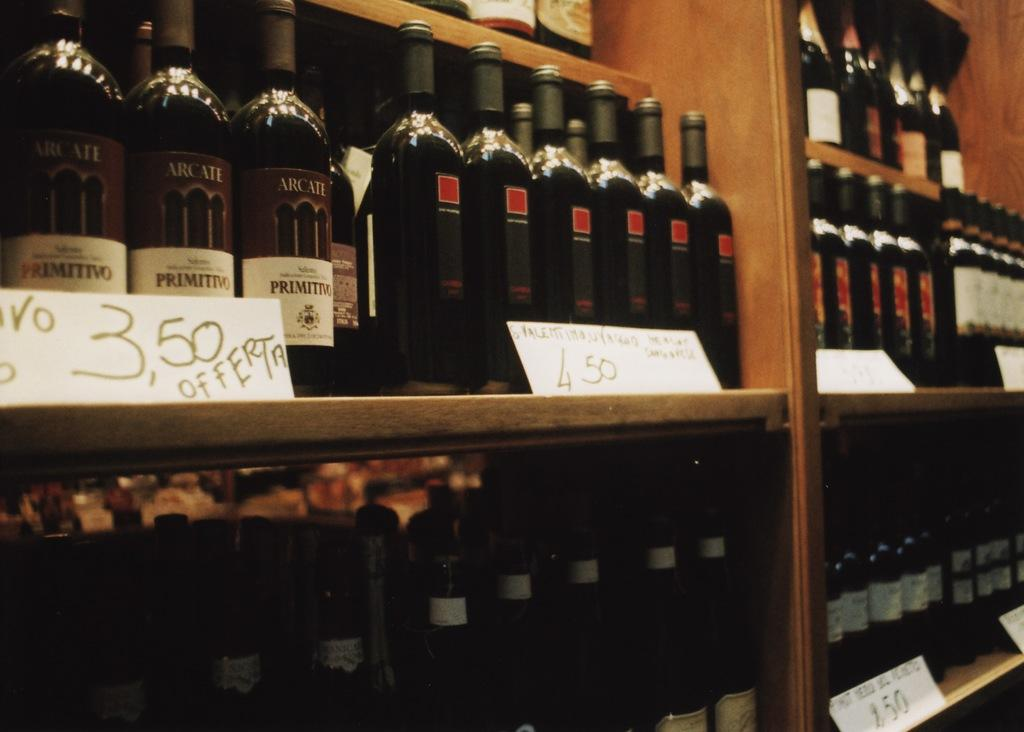<image>
Offer a succinct explanation of the picture presented. Several bottles of Arcate Primitivo wine lining the shelves along several other brands. 